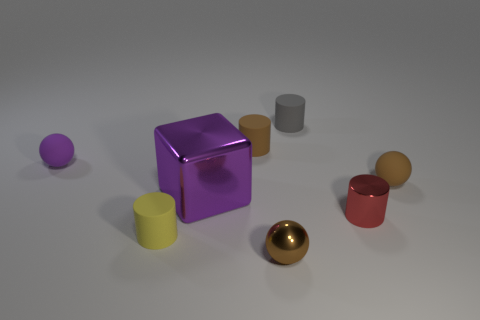The yellow thing that is the same shape as the red shiny object is what size?
Make the answer very short. Small. Are there more purple matte objects than large yellow balls?
Ensure brevity in your answer.  Yes. What number of big cyan metallic things are there?
Your answer should be compact. 0. What is the shape of the brown matte object that is behind the object that is to the right of the cylinder that is right of the small gray matte cylinder?
Provide a succinct answer. Cylinder. Is the number of brown rubber spheres that are behind the yellow rubber object less than the number of small rubber objects that are on the left side of the purple cube?
Ensure brevity in your answer.  Yes. Do the matte object in front of the purple metallic cube and the tiny brown matte thing that is on the left side of the tiny gray rubber cylinder have the same shape?
Your answer should be compact. Yes. What shape is the purple rubber object behind the brown matte thing that is to the right of the gray rubber cylinder?
Offer a terse response. Sphere. Are there any gray balls made of the same material as the tiny yellow object?
Your answer should be very brief. No. There is a ball in front of the brown rubber sphere; what is it made of?
Ensure brevity in your answer.  Metal. What is the material of the tiny red cylinder?
Your answer should be very brief. Metal. 